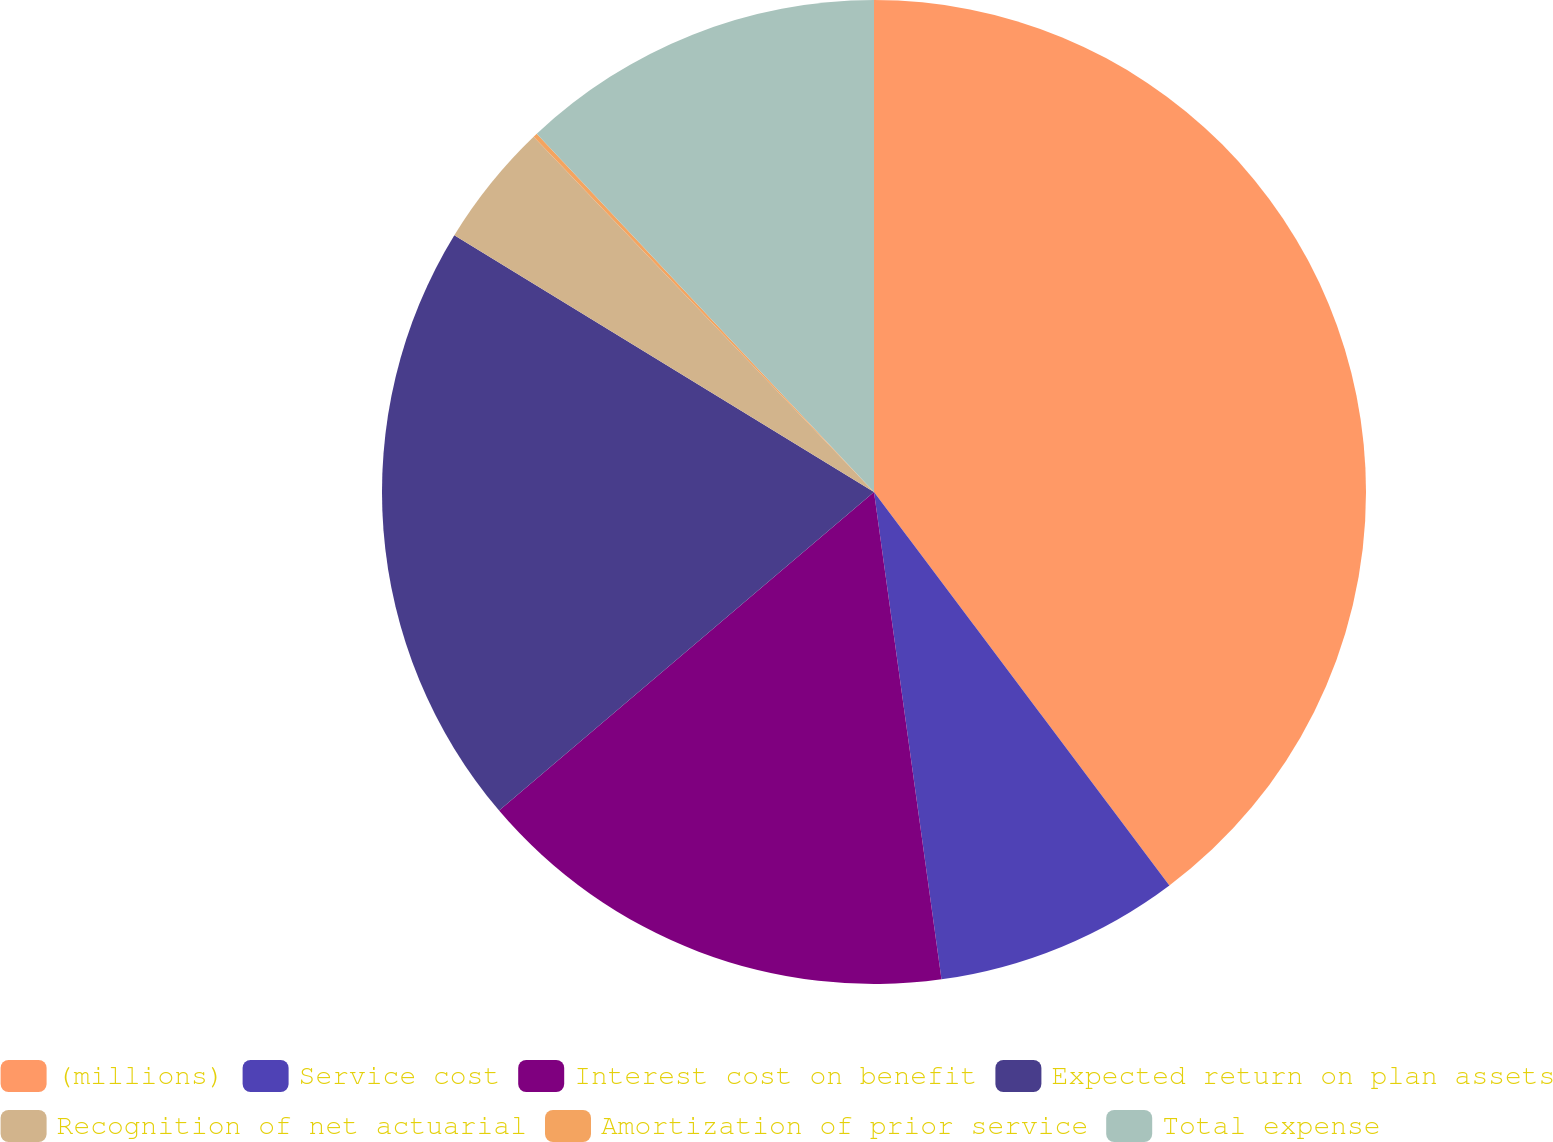<chart> <loc_0><loc_0><loc_500><loc_500><pie_chart><fcel>(millions)<fcel>Service cost<fcel>Interest cost on benefit<fcel>Expected return on plan assets<fcel>Recognition of net actuarial<fcel>Amortization of prior service<fcel>Total expense<nl><fcel>39.75%<fcel>8.06%<fcel>15.98%<fcel>19.95%<fcel>4.1%<fcel>0.14%<fcel>12.02%<nl></chart> 